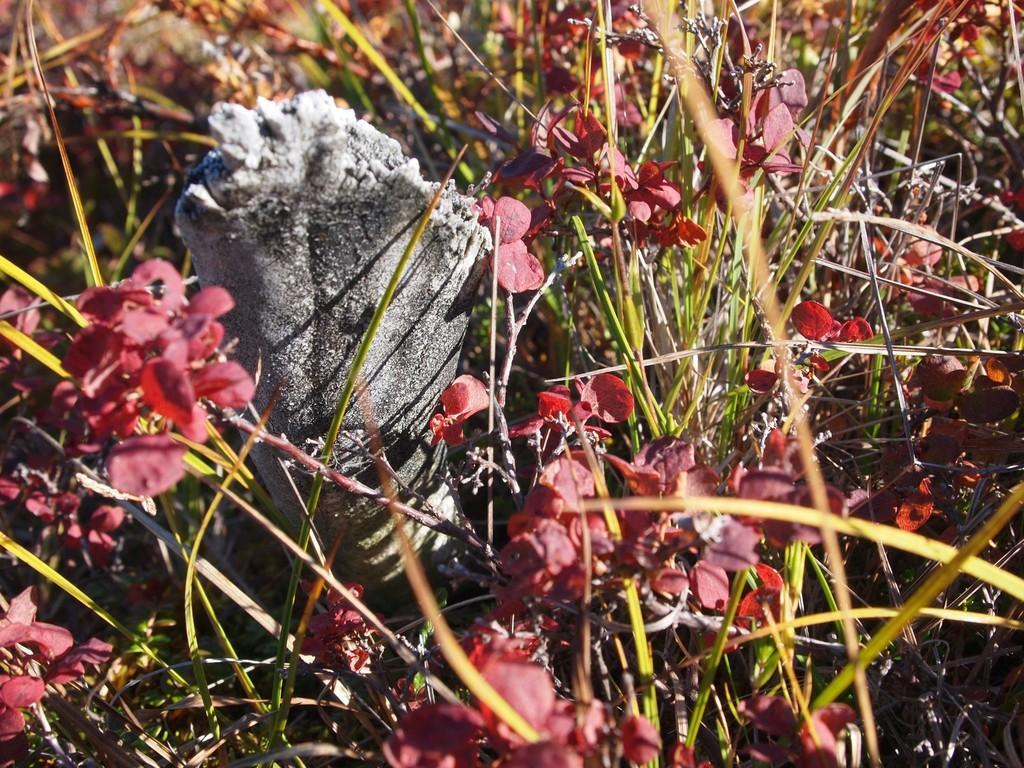Please provide a concise description of this image. In this image I can see the grass and few plants. On the left side there is an object on the ground. 